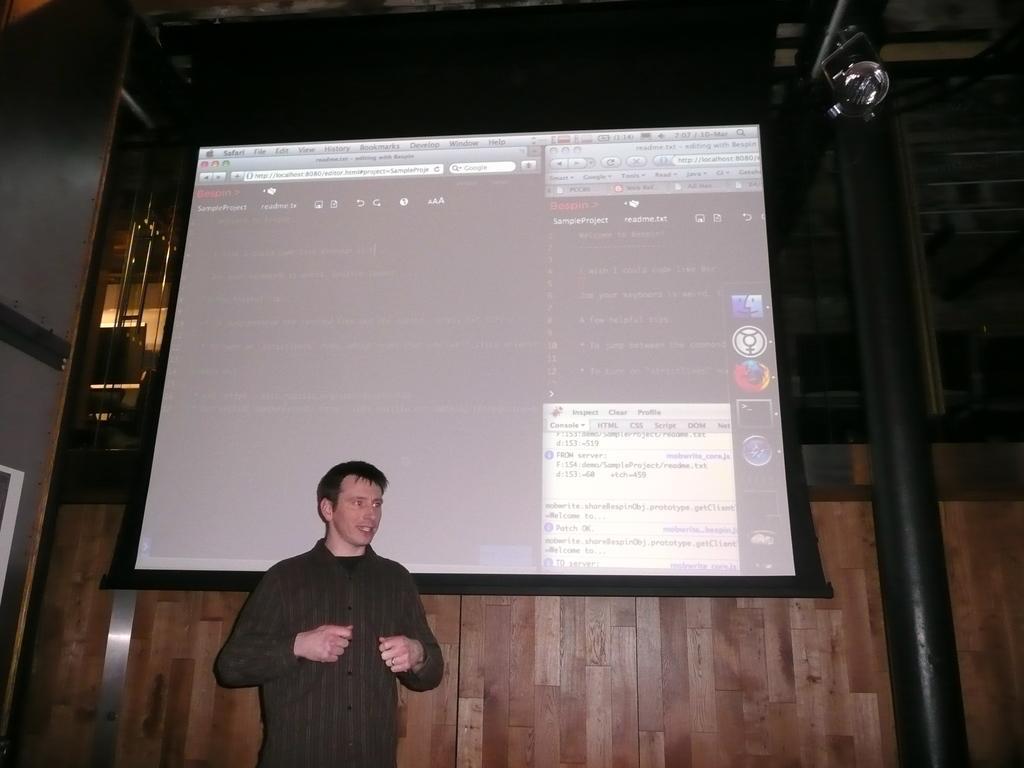Please provide a concise description of this image. In this image we can see this person is standing here. Here we can see the projector screen on which something is displayed, we can see the pillar, light, wooden wall and this part of the image is dark. 